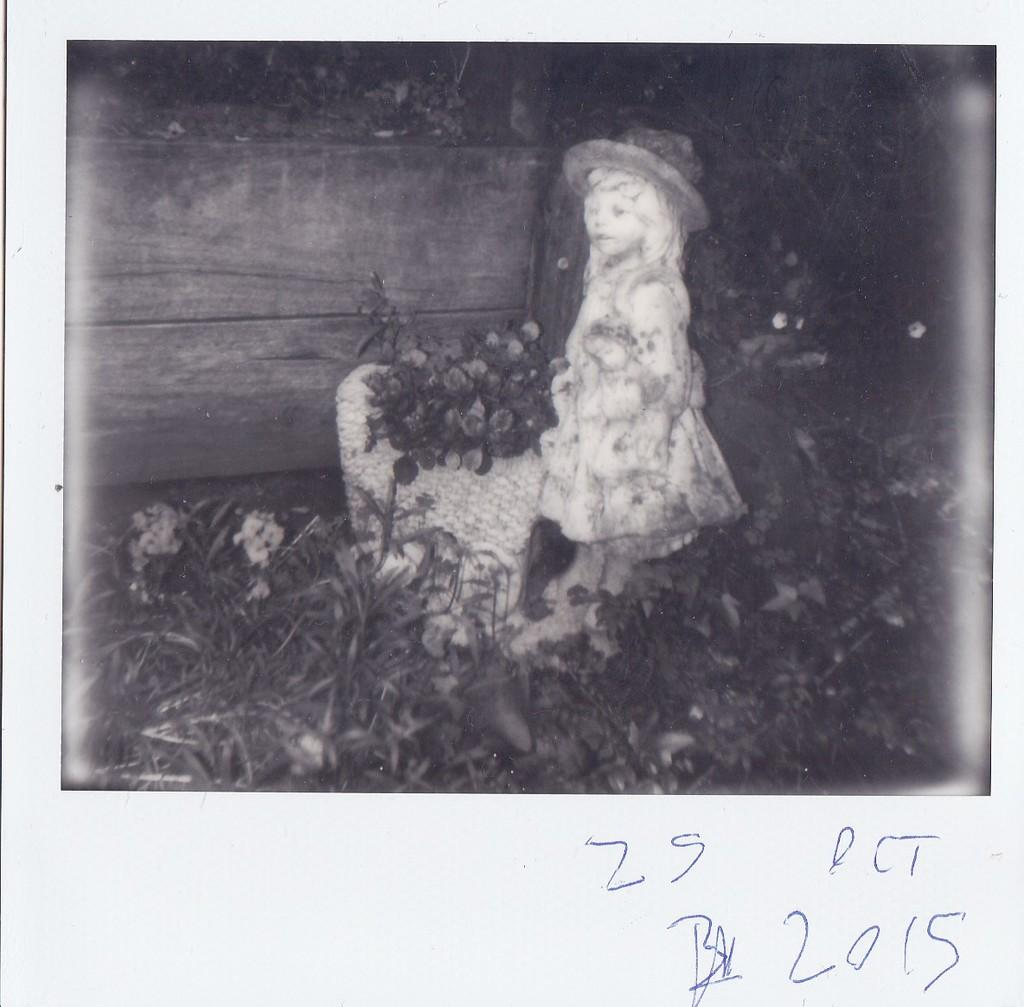Who is the main subject in the image? There is a girl in the center of the image. What can be seen at the bottom of the image? There are plants at the bottom of the image. Is there any text present in the image? Yes, there is some text written at the bottom of the image. What type of request is the girl making in the image? There is no indication of a request being made in the image; the girl is simply the main subject. 